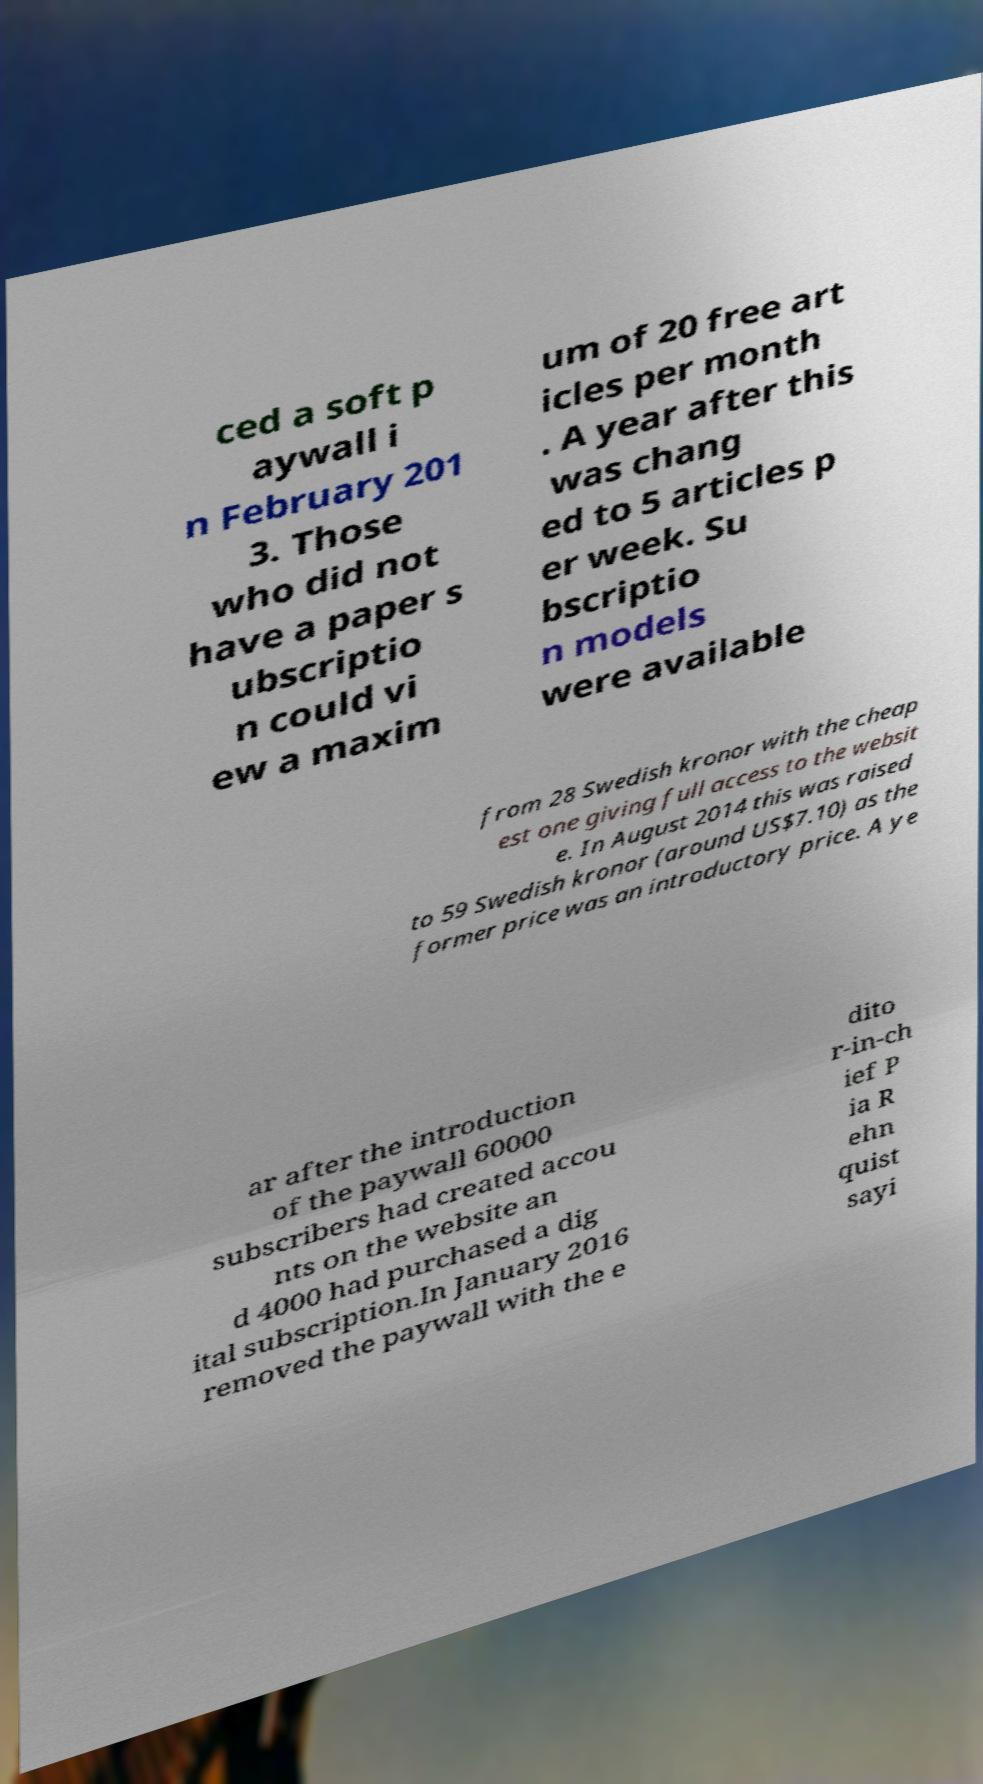For documentation purposes, I need the text within this image transcribed. Could you provide that? ced a soft p aywall i n February 201 3. Those who did not have a paper s ubscriptio n could vi ew a maxim um of 20 free art icles per month . A year after this was chang ed to 5 articles p er week. Su bscriptio n models were available from 28 Swedish kronor with the cheap est one giving full access to the websit e. In August 2014 this was raised to 59 Swedish kronor (around US$7.10) as the former price was an introductory price. A ye ar after the introduction of the paywall 60000 subscribers had created accou nts on the website an d 4000 had purchased a dig ital subscription.In January 2016 removed the paywall with the e dito r-in-ch ief P ia R ehn quist sayi 